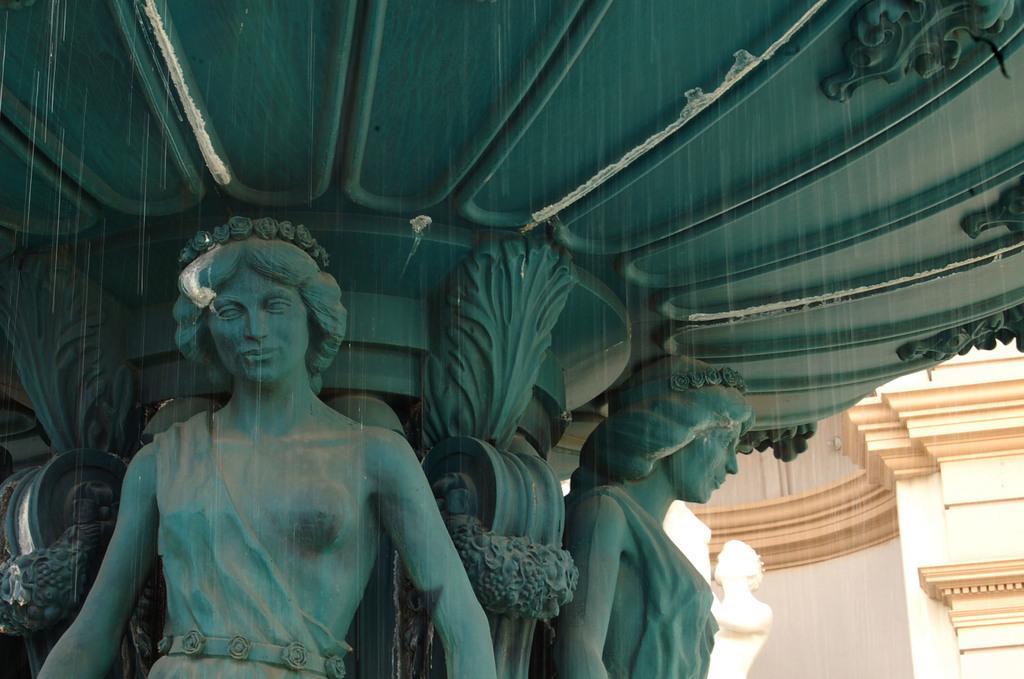How would you summarize this image in a sentence or two? In this image, I can see the sculptures. At the bottom right side of the image, It looks like a building. 